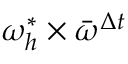<formula> <loc_0><loc_0><loc_500><loc_500>\omega _ { h } ^ { * } \times \bar { \omega } ^ { \Delta t }</formula> 